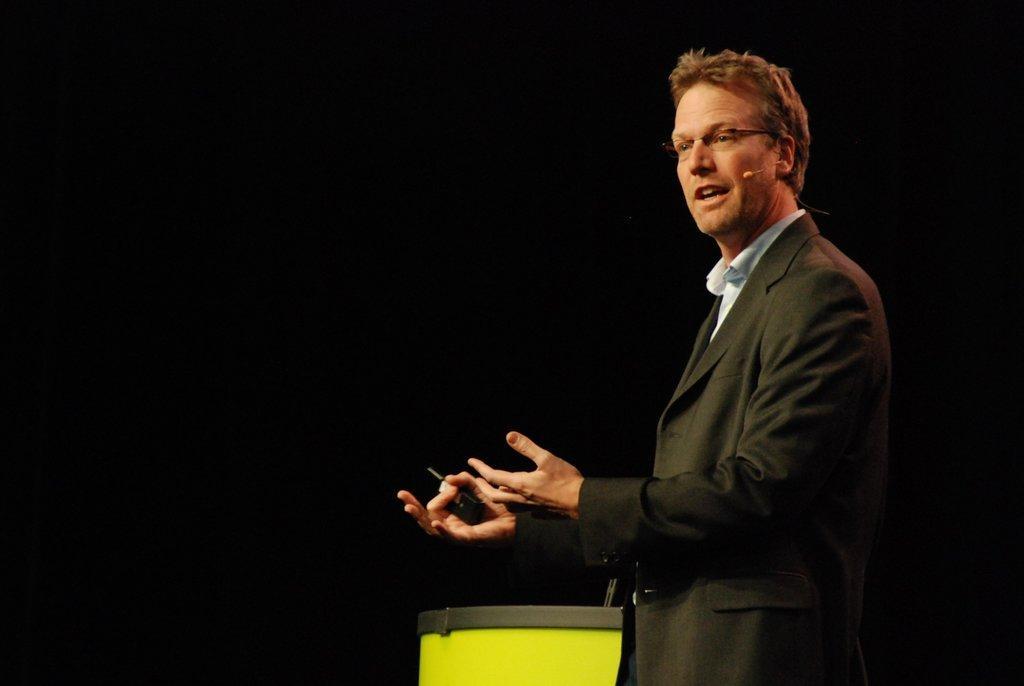Can you describe this image briefly? On the right side of the image a man is standing and wearing spectacles, microphone and holding an object. At the bottom of the image there is a podium. On podium we can see a mic. In the background the image is dark. 